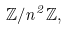<formula> <loc_0><loc_0><loc_500><loc_500>\mathbb { Z } / n ^ { 2 } \mathbb { Z } ,</formula> 